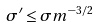Convert formula to latex. <formula><loc_0><loc_0><loc_500><loc_500>\sigma ^ { \prime } \leq \sigma m ^ { - 3 / 2 }</formula> 